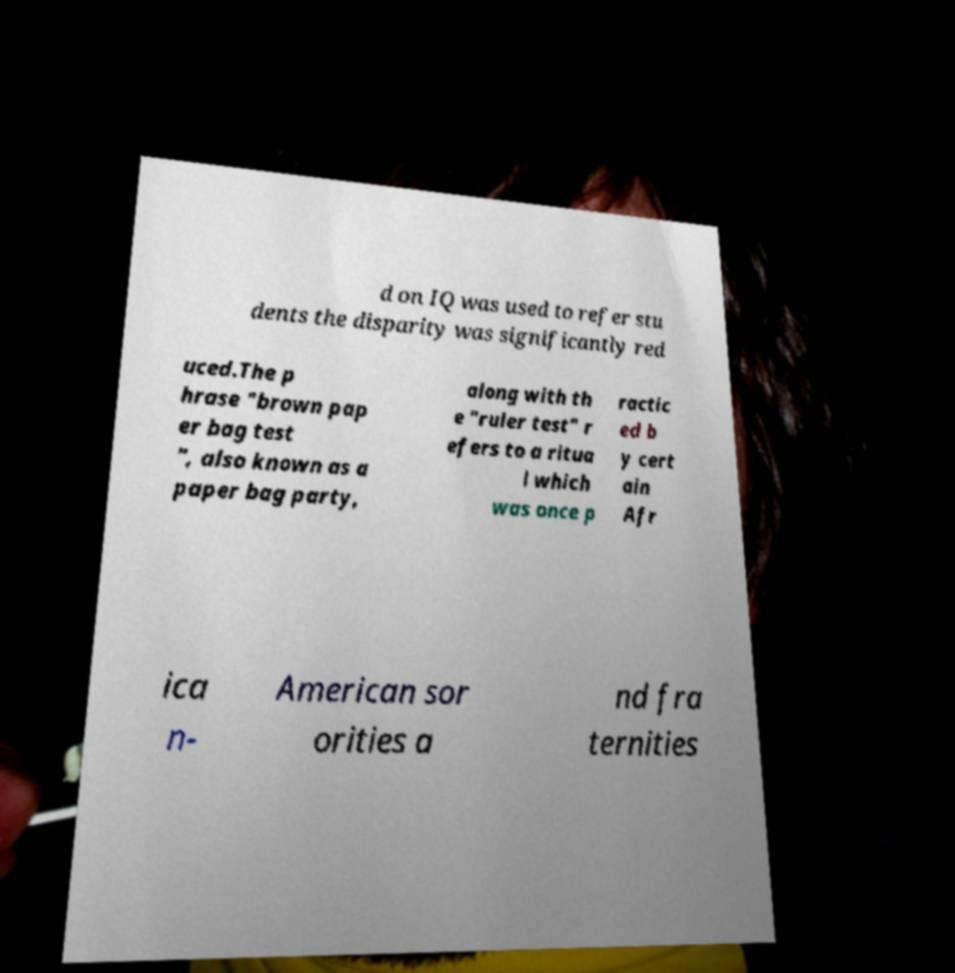Could you extract and type out the text from this image? d on IQ was used to refer stu dents the disparity was significantly red uced.The p hrase "brown pap er bag test ", also known as a paper bag party, along with th e "ruler test" r efers to a ritua l which was once p ractic ed b y cert ain Afr ica n- American sor orities a nd fra ternities 